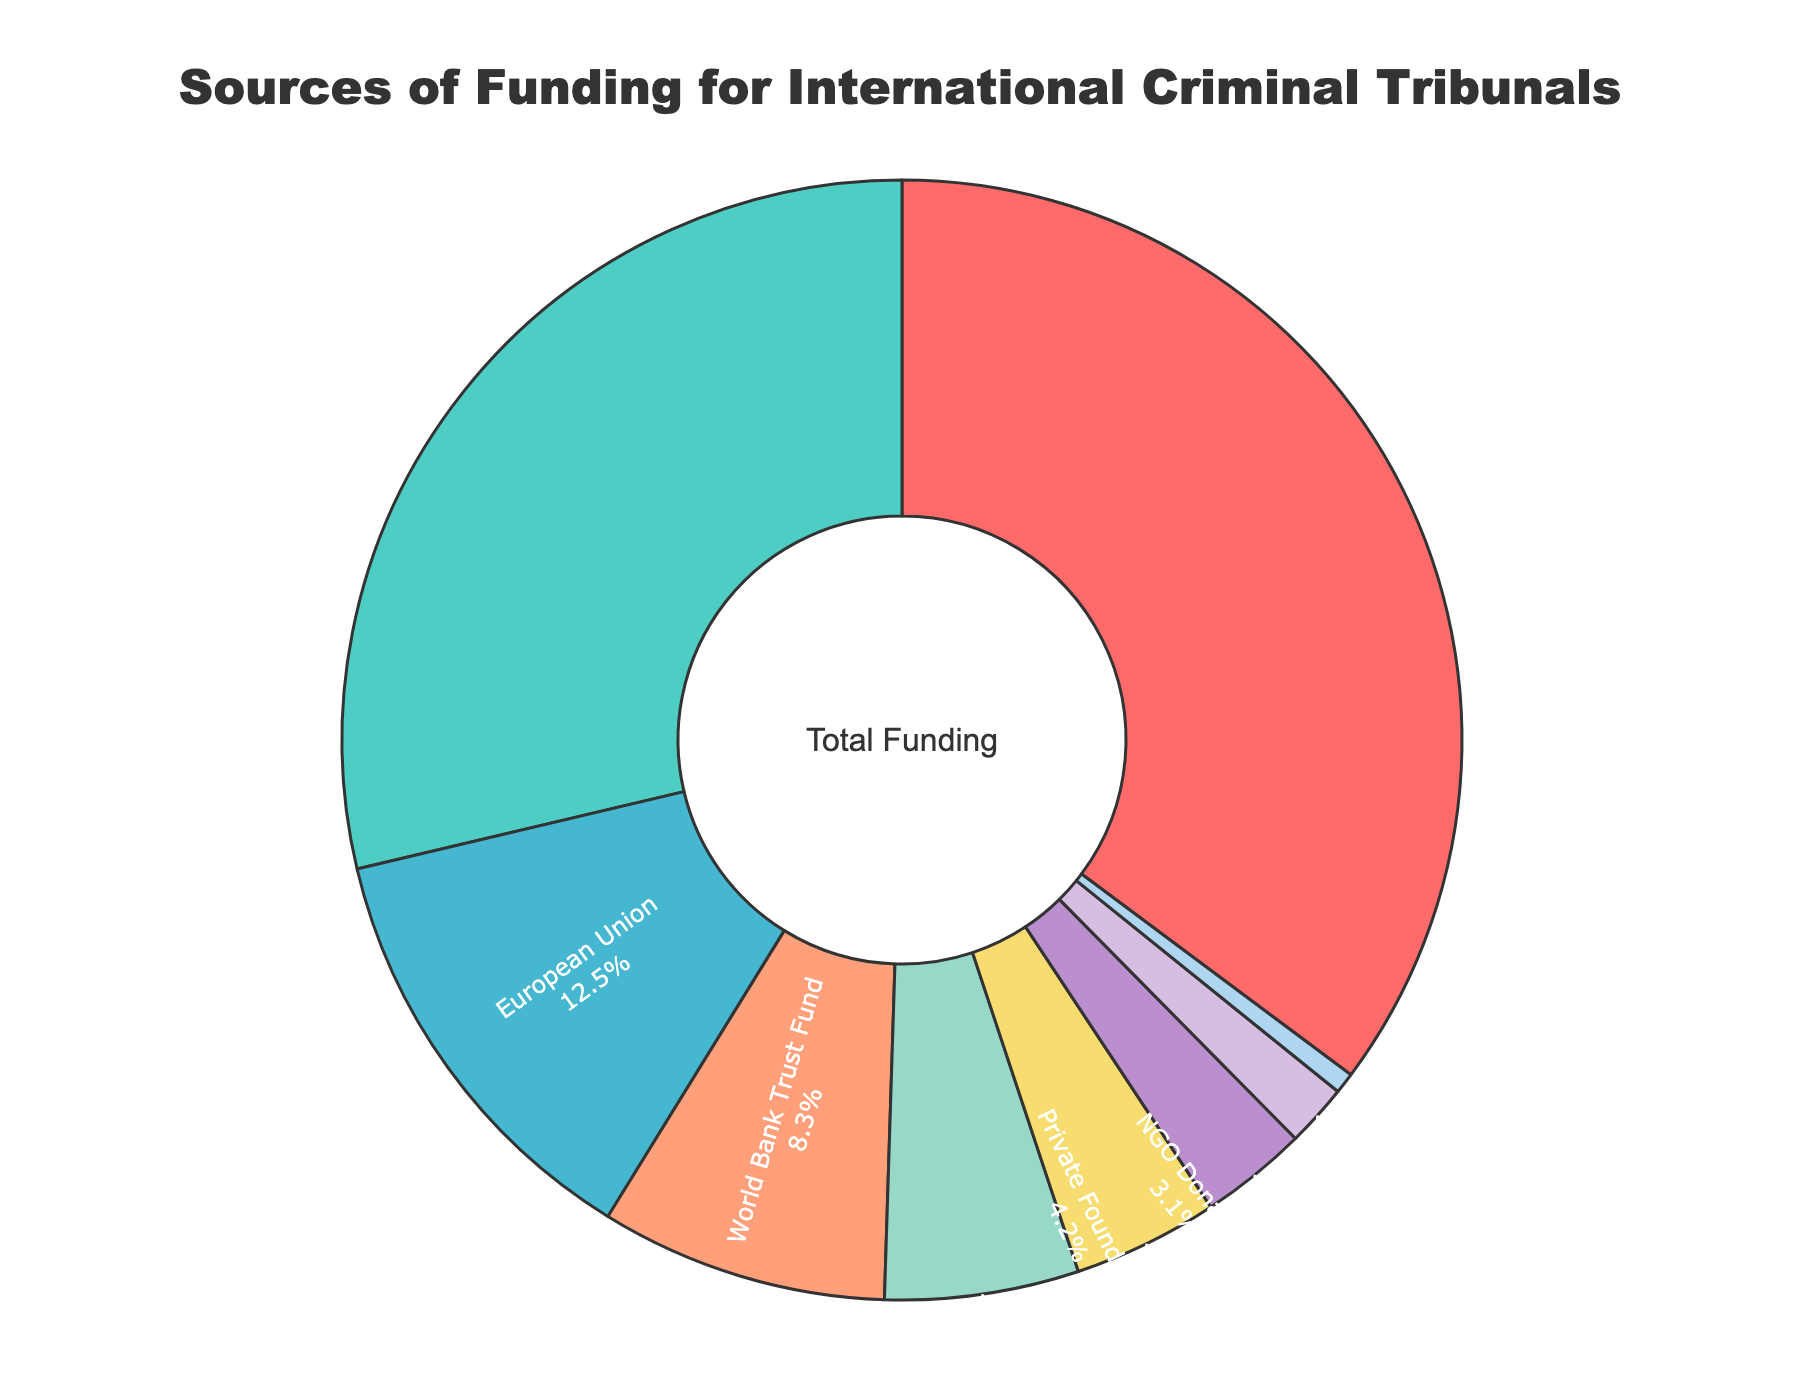What source provides the highest percentage of funding? By visually inspecting the pie chart, the largest segment can be easily identified. The label of this segment shows both the source and the percentage.
Answer: United Nations Regular Budget Which two sources together contribute more than 50% of the funding? First, identify the two largest segments in the chart. Then, add their respective percentages to see if their sum exceeds 50%. The largest are United Nations Regular Budget (35.2%) and Voluntary Contributions from States (28.7%). This sums to 63.9%.
Answer: United Nations Regular Budget and Voluntary Contributions from States Which source contributes more to funding: the European Union or the World Bank Trust Fund? Compare the size and associated percentage labels of both segments. The European Union contributes 12.5%, while the World Bank Trust Fund contributes 8.3%.
Answer: European Union How much more does Private Foundations contribute compared to NGO Donations? Identify the segments for Private Foundations and NGO Donations. Subtract the percentage of NGO Donations (3.1%) from the percentage of Private Foundations (4.2%). The difference is 1.1%.
Answer: 1.1% What is the combined contribution of the International Criminal Court Trust Fund and Private Foundations? Add the percentages of International Criminal Court Trust Fund (5.6%) and Private Foundations (4.2%). The total is 9.8%.
Answer: 9.8% Is the contribution from Asset Forfeiture Proceeds more than 2%? Find the segment for Asset Forfeiture Proceeds and check its percentage label. It shows 1.8%, which is less than 2%.
Answer: No Which source has the smallest contribution and what is its percentage? Look for the smallest segment in the pie chart and read its label. The smallest segment is for Academic Institutions with a contribution of 0.6%.
Answer: Academic Institutions How many sources contribute less than 10% each? Count the number of segments with percentages shown less than 10%. These are: World Bank Trust Fund (8.3%), International Criminal Court Trust Fund (5.6%), Private Foundations (4.2%), NGO Donations (3.1%), Asset Forfeiture Proceeds (1.8%), and Academic Institutions (0.6%). There are 6 sources.
Answer: 6 What percentage of the total funding comes from NGO Donations? Locate the segment for NGO Donations and read its percentage. The selected label indicates 3.1%.
Answer: 3.1% By how much does the contribution of the United Nations Regular Budget exceed the combined contribution of the International Criminal Court Trust Fund and Private Foundations? Add the percentages of the International Criminal Court Trust Fund (5.6%) and Private Foundations (4.2%), which equals 9.8%. Subtract this sum from the United Nations Regular Budget's percentage (35.2%). The difference is 25.4%.
Answer: 25.4% 